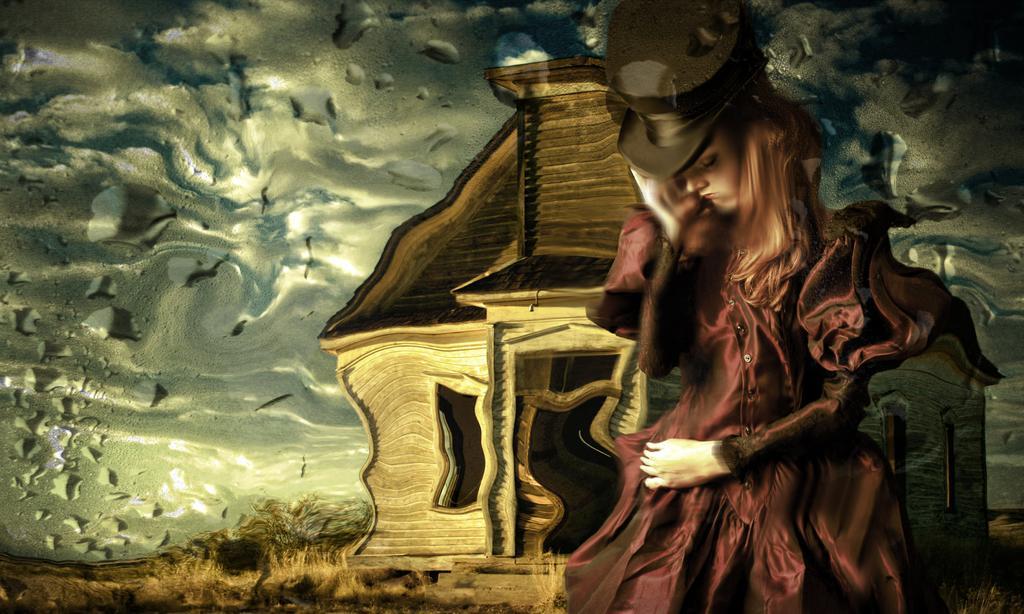In one or two sentences, can you explain what this image depicts? This image is a cartoon image. In this image we can see women, house, trees and grass. 